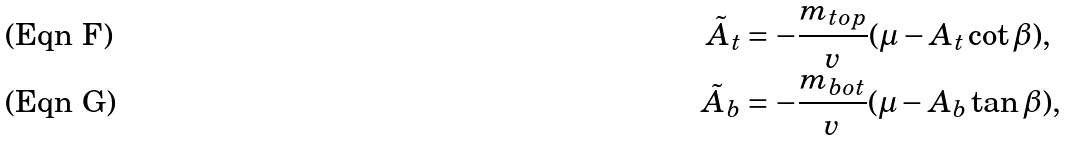<formula> <loc_0><loc_0><loc_500><loc_500>\tilde { A } _ { t } & = - \frac { m _ { t o p } } { v } ( \mu - A _ { t } \cot \beta ) , \\ \tilde { A } _ { b } & = - \frac { m _ { b o t } } { v } ( \mu - A _ { b } \tan \beta ) ,</formula> 